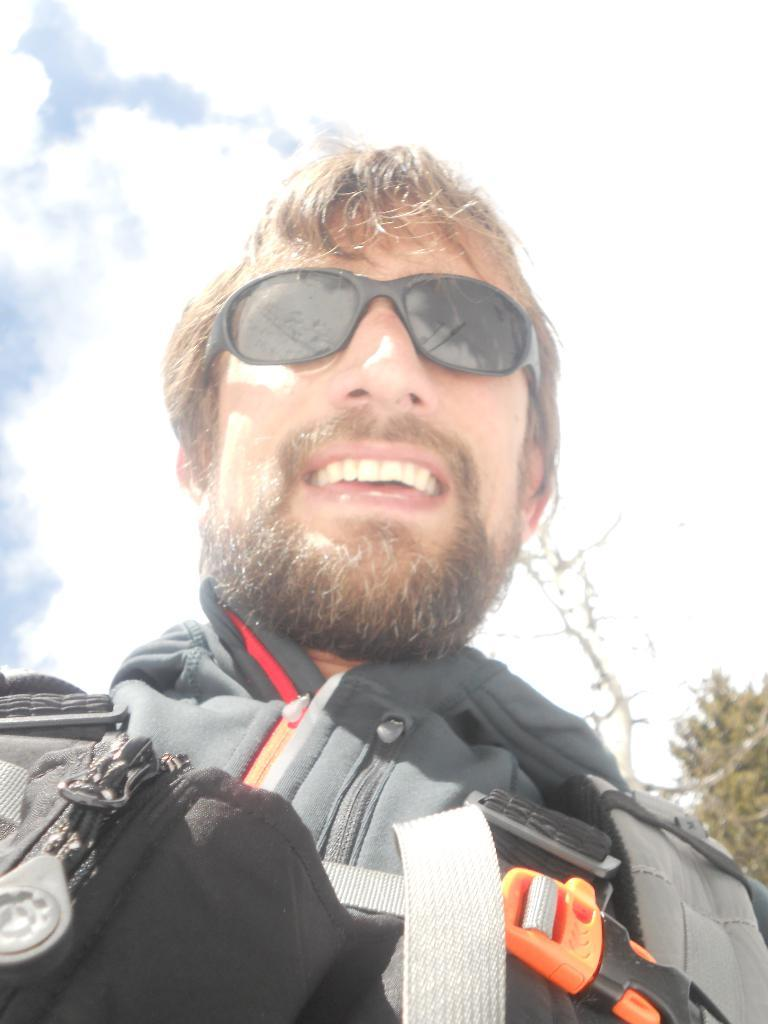Who is present in the image? There is a man in the image. What is the man wearing? The man is wearing clothes and spectacles. What is the man's facial expression? The man is smiling. What can be seen in the background of the image? There is a tree in the image. How would you describe the weather based on the image? The sky is cloudy in the image. What type of orange is the man holding in the image? There is no orange present in the image. How many books can be seen on the tree in the image? There are no books visible in the image; only a tree is present. 